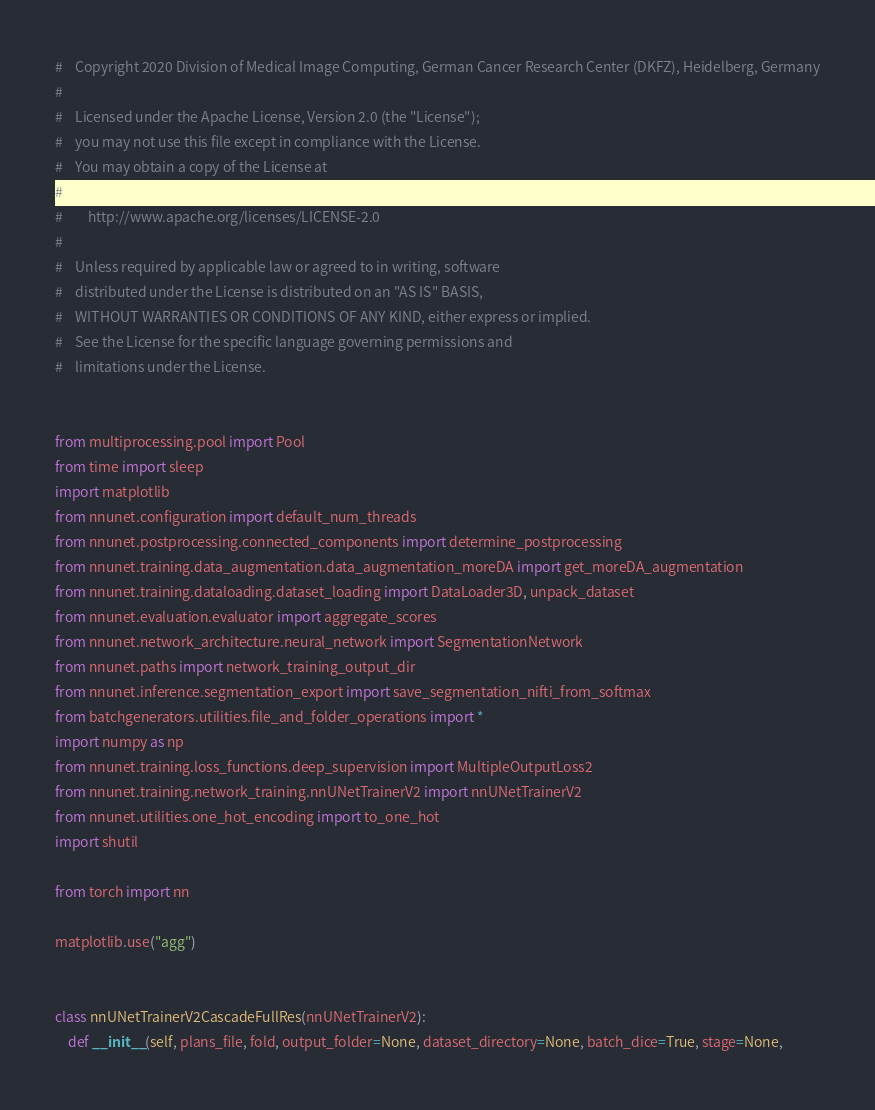<code> <loc_0><loc_0><loc_500><loc_500><_Python_>#    Copyright 2020 Division of Medical Image Computing, German Cancer Research Center (DKFZ), Heidelberg, Germany
#
#    Licensed under the Apache License, Version 2.0 (the "License");
#    you may not use this file except in compliance with the License.
#    You may obtain a copy of the License at
#
#        http://www.apache.org/licenses/LICENSE-2.0
#
#    Unless required by applicable law or agreed to in writing, software
#    distributed under the License is distributed on an "AS IS" BASIS,
#    WITHOUT WARRANTIES OR CONDITIONS OF ANY KIND, either express or implied.
#    See the License for the specific language governing permissions and
#    limitations under the License.


from multiprocessing.pool import Pool
from time import sleep
import matplotlib
from nnunet.configuration import default_num_threads
from nnunet.postprocessing.connected_components import determine_postprocessing
from nnunet.training.data_augmentation.data_augmentation_moreDA import get_moreDA_augmentation
from nnunet.training.dataloading.dataset_loading import DataLoader3D, unpack_dataset
from nnunet.evaluation.evaluator import aggregate_scores
from nnunet.network_architecture.neural_network import SegmentationNetwork
from nnunet.paths import network_training_output_dir
from nnunet.inference.segmentation_export import save_segmentation_nifti_from_softmax
from batchgenerators.utilities.file_and_folder_operations import *
import numpy as np
from nnunet.training.loss_functions.deep_supervision import MultipleOutputLoss2
from nnunet.training.network_training.nnUNetTrainerV2 import nnUNetTrainerV2
from nnunet.utilities.one_hot_encoding import to_one_hot
import shutil

from torch import nn

matplotlib.use("agg")


class nnUNetTrainerV2CascadeFullRes(nnUNetTrainerV2):
    def __init__(self, plans_file, fold, output_folder=None, dataset_directory=None, batch_dice=True, stage=None,</code> 